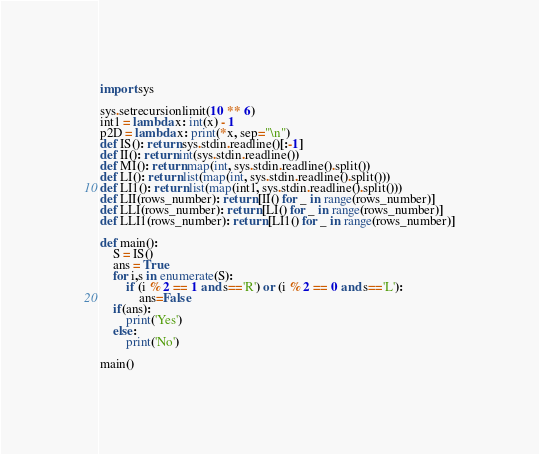<code> <loc_0><loc_0><loc_500><loc_500><_Python_>import sys

sys.setrecursionlimit(10 ** 6)
int1 = lambda x: int(x) - 1
p2D = lambda x: print(*x, sep="\n")
def IS(): return sys.stdin.readline()[:-1]
def II(): return int(sys.stdin.readline())
def MI(): return map(int, sys.stdin.readline().split())
def LI(): return list(map(int, sys.stdin.readline().split()))
def LI1(): return list(map(int1, sys.stdin.readline().split()))
def LII(rows_number): return [II() for _ in range(rows_number)]
def LLI(rows_number): return [LI() for _ in range(rows_number)]
def LLI1(rows_number): return [LI1() for _ in range(rows_number)]

def main():
	S = IS()
	ans = True
	for i,s in enumerate(S):
		if (i % 2 == 1 and s=='R') or (i % 2 == 0 and s=='L'):
			ans=False
	if(ans):
		print('Yes')
	else:
		print('No')

main()</code> 